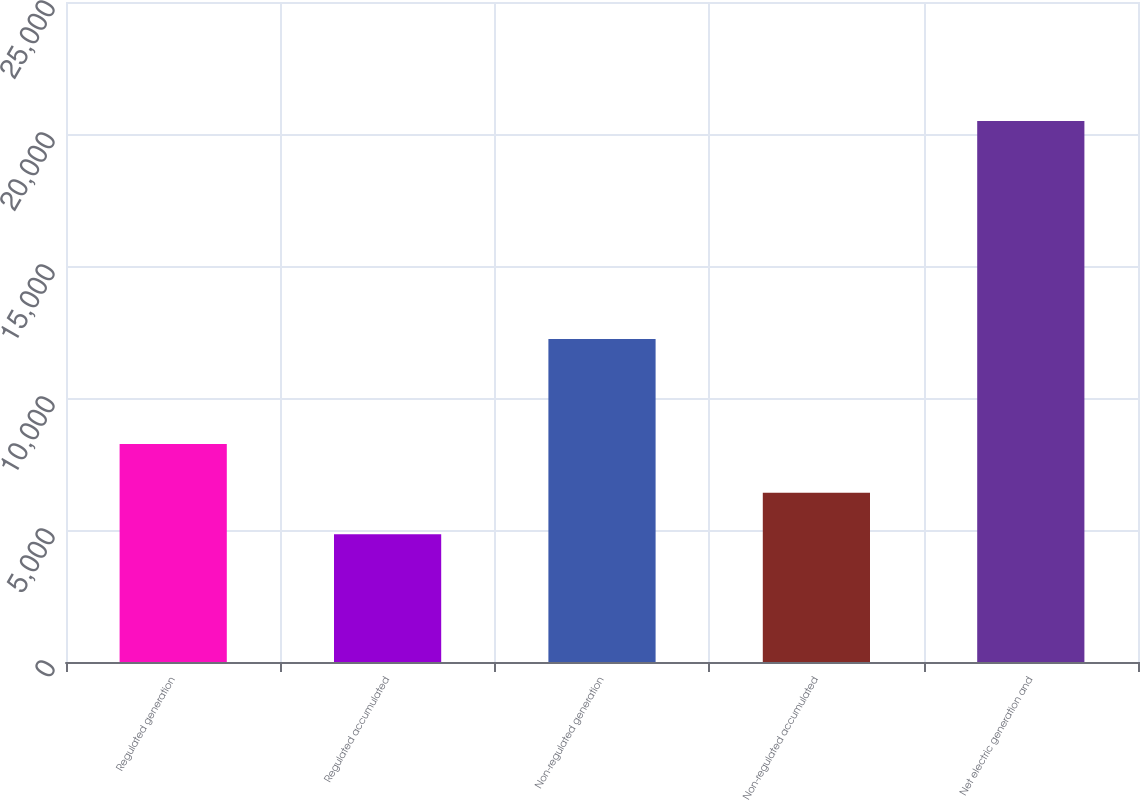Convert chart. <chart><loc_0><loc_0><loc_500><loc_500><bar_chart><fcel>Regulated generation<fcel>Regulated accumulated<fcel>Non-regulated generation<fcel>Non-regulated accumulated<fcel>Net electric generation and<nl><fcel>8262<fcel>4841<fcel>12235<fcel>6406.6<fcel>20497<nl></chart> 